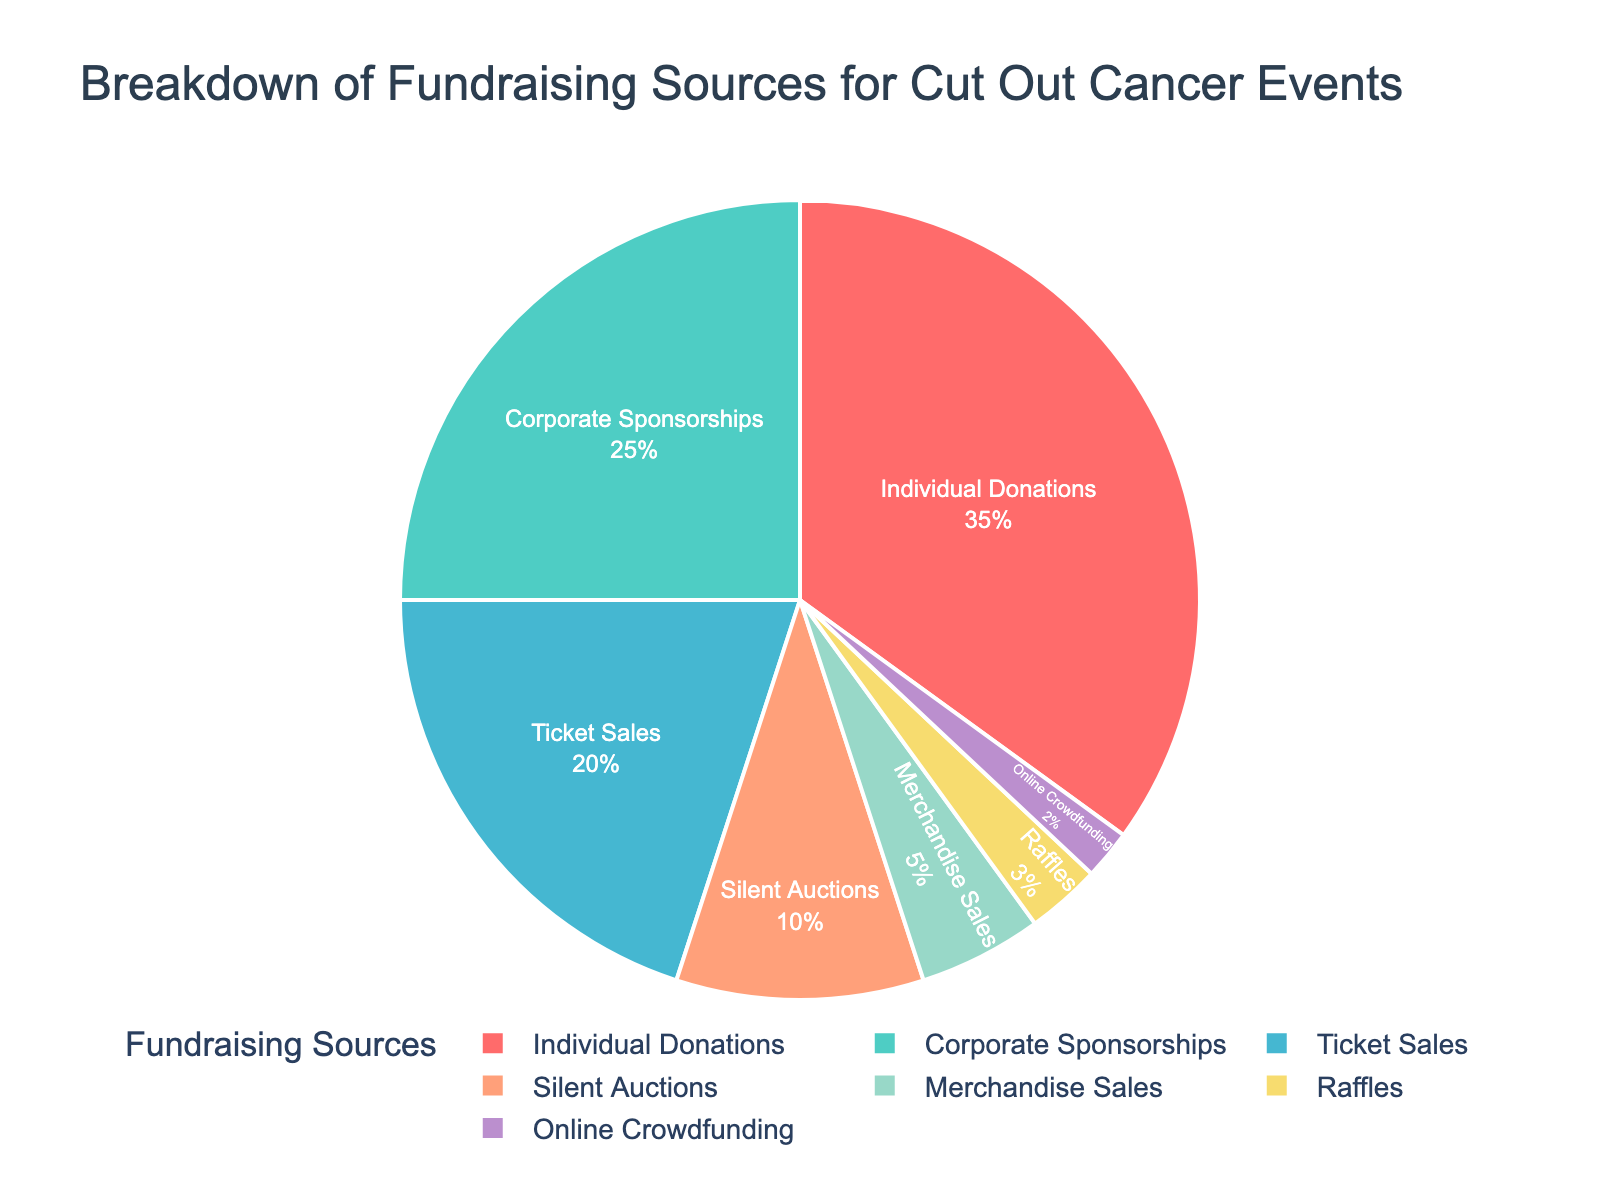Which category contributes the largest percentage to the fundraising? The figure shows a pie chart with different categories of fundraising sources. The slice labeled "Individual Donations" is the largest one, occupying 35% of the chart.
Answer: Individual Donations What is the combined percentage of Corporate Sponsorships and Ticket Sales? The figure lists Corporate Sponsorships at 25% and Ticket Sales at 20%. Adding these percentages, 25 + 20, gives us the combined percentage.
Answer: 45% How much more does Individual Donations contribute compared to Merchandise Sales? Individual Donations contribute 35% while Merchandise Sales contribute 5%. The difference is calculated by subtracting 5 from 35.
Answer: 30% Which source contributes the least to the fundraising? By looking at the smallest slice of the pie chart, it is clear that "Online Crowdfunding" represents the smallest percentage at 2%.
Answer: Online Crowdfunding Are the combined contributions of Silent Auctions and Raffles greater than Ticket Sales? Silent Auctions is 10% and Raffles is 3%, combined they make 13%. Ticket Sales is 20%. Since 13% is not greater than 20%, the combined contributions are not greater.
Answer: No What is the total percentage for all fundraising sources not exceeding 10% individually? Adding the percentages of Silent Auctions (10%), Merchandise Sales (5%), Raffles (3%), and Online Crowdfunding (2%), we get 10 + 5 + 3 + 2.
Answer: 20% Which fundraising source is represented by the green color in the pie chart? By examining the color scheme provided in the data, the green color corresponds to the "Corporate Sponsorships" slice.
Answer: Corporate Sponsorships Are Individual Donations and Corporate Sponsorships together more than half of the total fundraising sources? Yes, Individual Donations contribute 35% and Corporate Sponsorships contribute 25%. Together, they add up to 60%, which is more than half.
Answer: Yes What is the difference in contribution percentage between Ticket Sales and Silent Auctions? Ticket Sales contribute 20%, and Silent Auctions contribute 10%. Subtracting 10 from 20 gives the difference.
Answer: 10% If you sum up the percentages of Corporate Sponsorships and Merchandise Sales, is it more or less than half of the total fundraising? Corporate Sponsorships is 25% and Merchandise Sales is 5%. Their sum is 25 + 5 which equals 30%, less than half of 100%.
Answer: Less 